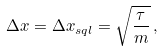<formula> <loc_0><loc_0><loc_500><loc_500>\Delta x = \Delta x _ { s q l } = \sqrt { \frac { \tau } { m } } \, ,</formula> 